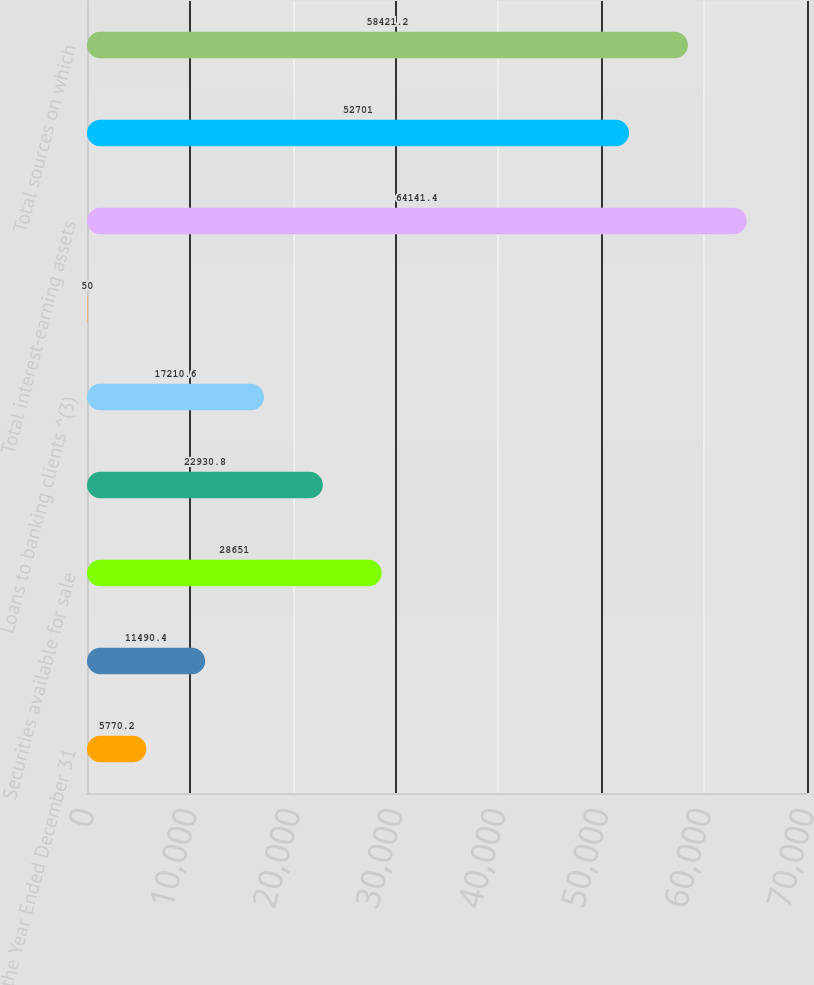Convert chart. <chart><loc_0><loc_0><loc_500><loc_500><bar_chart><fcel>For the Year Ended December 31<fcel>Cash and cash equivalents^ (1)<fcel>Securities available for sale<fcel>Securities held to maturity<fcel>Loans to banking clients ^(3)<fcel>Other interest-earning assets<fcel>Total interest-earning assets<fcel>Interest-bearing banking<fcel>Total sources on which<nl><fcel>5770.2<fcel>11490.4<fcel>28651<fcel>22930.8<fcel>17210.6<fcel>50<fcel>64141.4<fcel>52701<fcel>58421.2<nl></chart> 